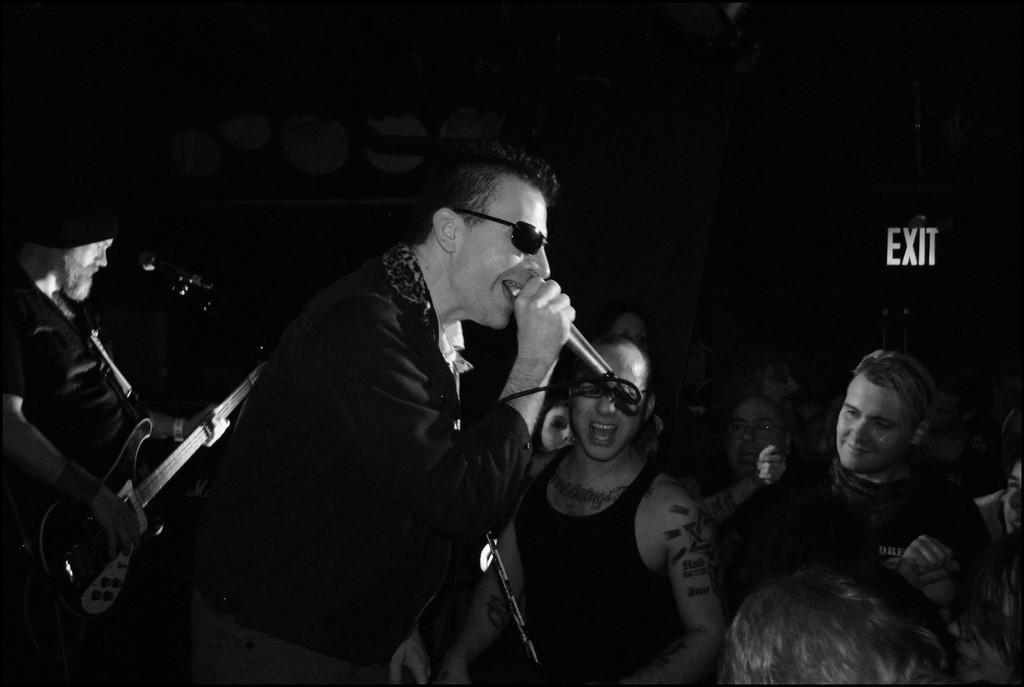Can you describe this image briefly? There are some group of people in the picture. One guy is holding a mic in his hand and singing. He is wearing a spectacles. In the background there is another guy playing a guitar, remaining people are enjoying the concert. 